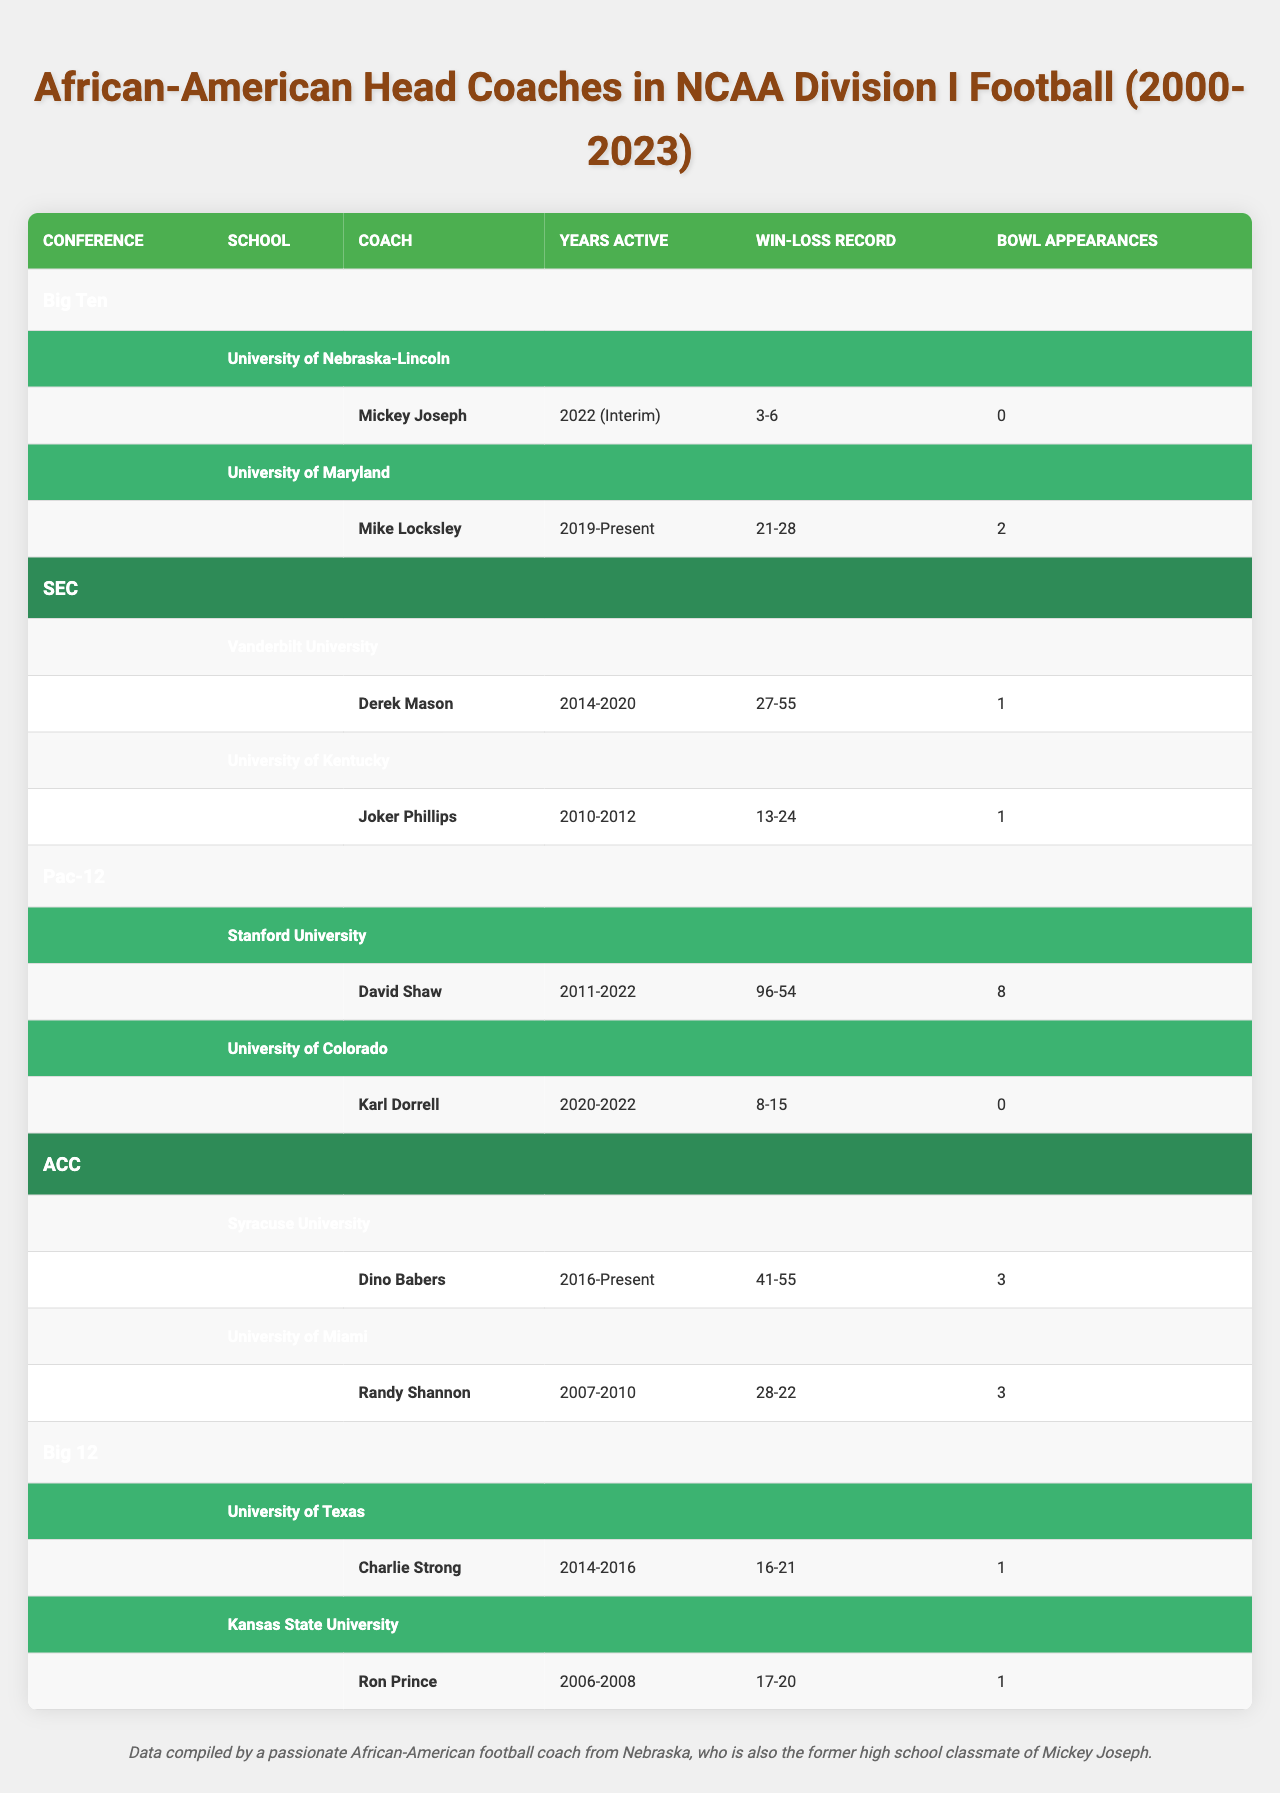What is the win-loss record of Mickey Joseph? The win-loss record for Mickey Joseph, who coached at the University of Nebraska-Lincoln, is listed as 3-6.
Answer: 3-6 How many bowl appearances did Mike Locksley have at the University of Maryland? Mike Locksley, the head coach at the University of Maryland, had 2 bowl appearances according to the data.
Answer: 2 Which coach had the most bowl appearances and how many? David Shaw from Stanford University had the most bowl appearances listed, totaling 8 bowl appearances.
Answer: 8 In which conference did Derek Mason coach? Derek Mason coached in the SEC (Southeastern Conference). This is identified in the conference column associated with his school, Vanderbilt University.
Answer: SEC What is the average win-loss record of the coaches in the ACC? The win-loss records for the ACC coaches are: Dino Babers (41-55) and Randy Shannon (28-22). This can be expressed numerically as -14 (41 - 55 = -14) for Babers and 6 (28 - 22 = 6) for Shannon. To find the average, we sum (-14 + 6) = -8 and divide by 2, resulting in -4 for the average win-loss record.
Answer: -4 Did Karl Dorrell make any bowl appearances during his tenure? Karl Dorrell, who coached at the University of Colorado, has 0 bowl appearances noted in the table, indicating he did not appear in any during his time.
Answer: No Which coach has the longest tenure and how many years was that? David Shaw, coaching at Stanford University, has the longest tenure, active from 2011 to 2022, representing 11 years in total.
Answer: 11 years How many coaches from the Big Ten had a positive win-loss record? Only one coach, Mike Locksley from the University of Maryland, had a slightly positive record (21-28) based on his win-loss comparison, but it is technically negative. Mickey Joseph (3-6) also has a negative record. Thus, there are no Big Ten coaches with a positive record.
Answer: 0 What is the total number of bowl appearances by the coaches in the SEC conference? The total number of bowl appearances by Derek Mason (1) and Joker Phillips (1) in the SEC is 1 + 1, resulting in a total of 2.
Answer: 2 Is there any coach in the Big 12 conference with more than 1 bowl appearance? Both Charlie Strong (1) and Ron Prince (1) have exactly 1 bowl appearance each under their records, indicating that there are none with more than 1.
Answer: No 